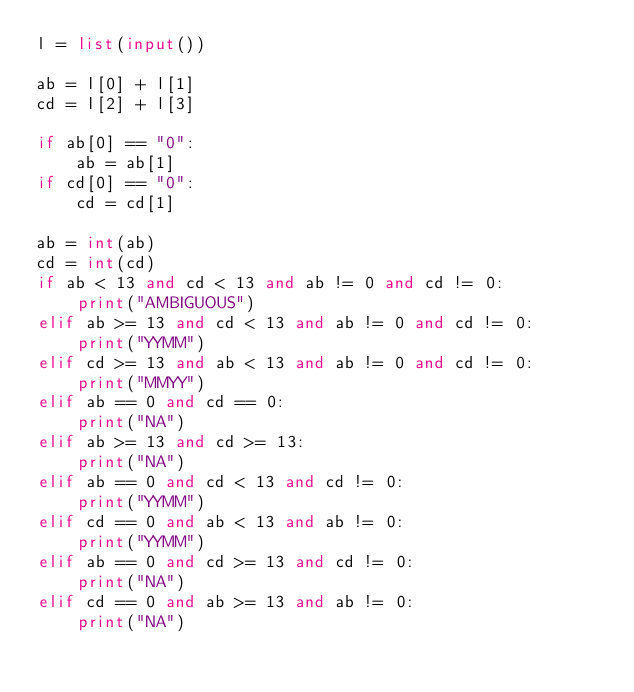<code> <loc_0><loc_0><loc_500><loc_500><_Python_>l = list(input())

ab = l[0] + l[1]
cd = l[2] + l[3]

if ab[0] == "0":
    ab = ab[1]
if cd[0] == "0":
    cd = cd[1]

ab = int(ab)
cd = int(cd)
if ab < 13 and cd < 13 and ab != 0 and cd != 0:
    print("AMBIGUOUS")
elif ab >= 13 and cd < 13 and ab != 0 and cd != 0:
    print("YYMM")
elif cd >= 13 and ab < 13 and ab != 0 and cd != 0:
    print("MMYY")
elif ab == 0 and cd == 0:
    print("NA")
elif ab >= 13 and cd >= 13:
    print("NA")
elif ab == 0 and cd < 13 and cd != 0:
    print("YYMM")
elif cd == 0 and ab < 13 and ab != 0:
    print("YYMM")
elif ab == 0 and cd >= 13 and cd != 0:
    print("NA")
elif cd == 0 and ab >= 13 and ab != 0:
    print("NA")
</code> 